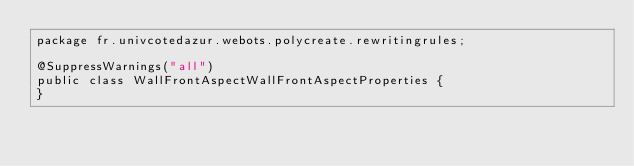Convert code to text. <code><loc_0><loc_0><loc_500><loc_500><_Java_>package fr.univcotedazur.webots.polycreate.rewritingrules;

@SuppressWarnings("all")
public class WallFrontAspectWallFrontAspectProperties {
}
</code> 